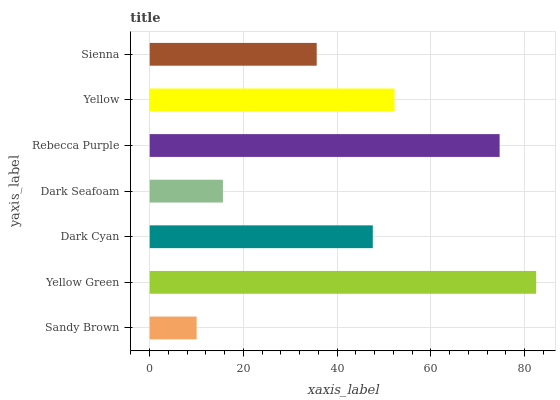Is Sandy Brown the minimum?
Answer yes or no. Yes. Is Yellow Green the maximum?
Answer yes or no. Yes. Is Dark Cyan the minimum?
Answer yes or no. No. Is Dark Cyan the maximum?
Answer yes or no. No. Is Yellow Green greater than Dark Cyan?
Answer yes or no. Yes. Is Dark Cyan less than Yellow Green?
Answer yes or no. Yes. Is Dark Cyan greater than Yellow Green?
Answer yes or no. No. Is Yellow Green less than Dark Cyan?
Answer yes or no. No. Is Dark Cyan the high median?
Answer yes or no. Yes. Is Dark Cyan the low median?
Answer yes or no. Yes. Is Sienna the high median?
Answer yes or no. No. Is Yellow the low median?
Answer yes or no. No. 